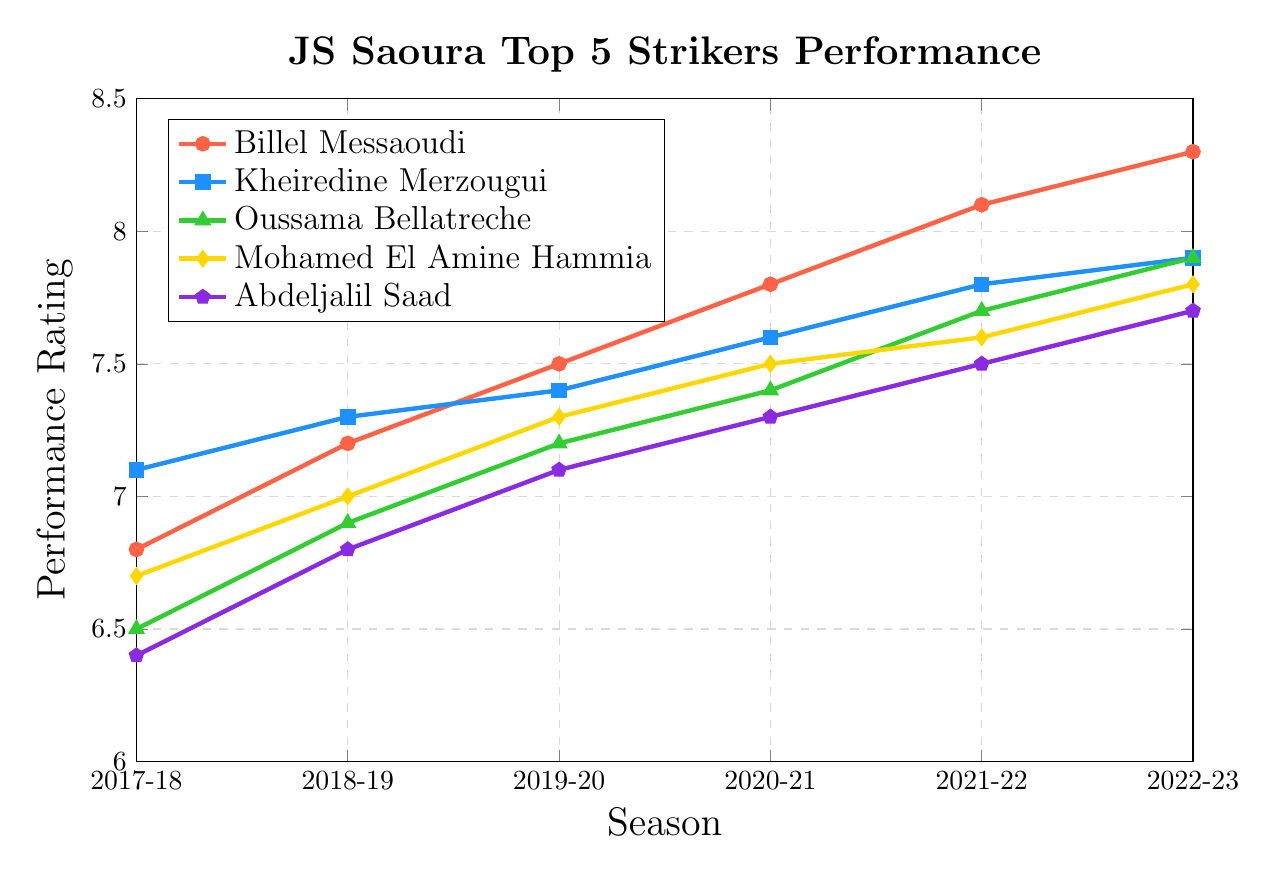What is the overall trend in Billel Messaoudi's performance rating from 2017-18 to 2022-23? Billel Messaoudi's performance rating shows an increasing trend from 6.8 in 2017-18 to 8.3 in 2022-23. To determine this, observe the data points connected by the line representing his performance over the seasons.
Answer: Increasing Which player had the highest performance rating in the 2021-22 season? In the 2021-22 season, Billel Messaoudi achieved the highest performance rating of 8.1 among all the players. This can be seen by comparing the y-values (performance ratings) at the x-position corresponding to 2021-22.
Answer: Billel Messaoudi Who had a greater improvement in performance rating from 2017-18 to 2022-23, Billel Messaoudi or Kheiredine Merzougui? The improvement in Billel Messaoudi's performance rating is 8.3 - 6.8 = 1.5. For Kheiredine Merzougui, it is 7.9 - 7.1 = 0.8. Comparing the two improvements, Billel Messaoudi had a greater increase.
Answer: Billel Messaoudi Which two players had the closest performance ratings in the 2019-20 season? In the 2019-20 season, Kheiredine Merzougui and Oussama Bellatreche had performance ratings of 7.4 and 7.2, respectively. The difference between their ratings is 0.2, which is the smallest among any pair in that season.
Answer: Kheiredine Merzougui and Oussama Bellatreche Which player showed the most consistent performance improvement over the seasons 2017-18 to 2022-23? To identify the most consistent improvement, we check the players' performance ratings over the seasons. Kheiredine Merzougui shows a steady increase from 7.1 to 7.9 with approximately consistent steps each season.
Answer: Kheiredine Merzougui Calculate the average performance rating of Mohamed El Amine Hammia over the six seasons. Mohamed El Amine Hammia's ratings are 6.7, 7.0, 7.3, 7.5, 7.6, and 7.8. Summing these gives 43.9. Dividing by 6 provides the average: 43.9 / 6 = 7.32.
Answer: 7.32 What was Abdeljalil Saad's performance rating difference between the 2018-19 and 2020-21 seasons? Abdeljalil Saad's performance rating was 6.8 in 2018-19 and 7.3 in 2020-21. The difference is 7.3 - 6.8 = 0.5.
Answer: 0.5 By observing the visual representation, which player's performance curve is represented by a pentagon marker? The pentagon markers on the plot represent Abdeljalil Saad's performance. This is indicated by the legend on the plot which associates the pentagon marker with his name.
Answer: Abdeljalil Saad Are there any seasons in which the performance ratings of all players fall within a 0.5-point range? In the 2017-18 season, the ratings range from Abdeljalil Saad's 6.4 to Kheiredine Merzougui's 7.1, a span of 0.7 which is more than 0.5. Similarly for other seasons, the ranges exceed 0.5. No single season has all ratings within a 0.5-point range.
Answer: No 